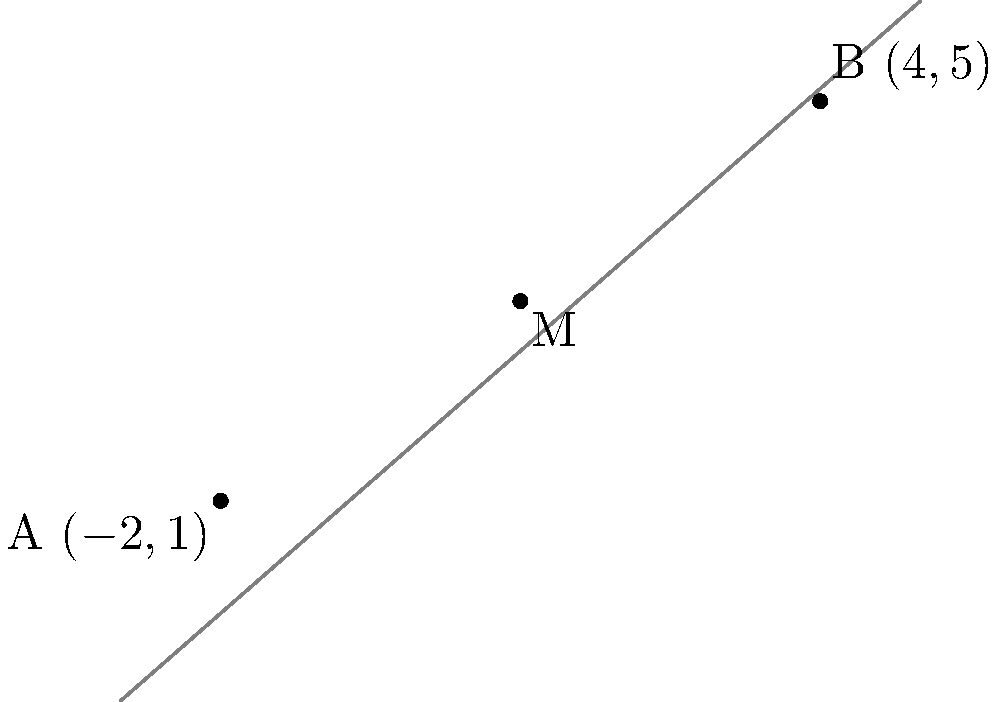As a rising star in your sport, you're analyzing team positions on a coordinate plane. Team Position 1 is at $(-2,1)$, and Team Position 2 is at $(4,5)$. To optimize your strategy, you need to find the midpoint between these two positions. What are the coordinates of this midpoint? To find the midpoint of a line segment connecting two points, we use the midpoint formula:

$$ M_x = \frac{x_1 + x_2}{2}, \quad M_y = \frac{y_1 + y_2}{2} $$

Where $(x_1, y_1)$ are the coordinates of the first point and $(x_2, y_2)$ are the coordinates of the second point.

For our problem:
1. Team Position 1: $(x_1, y_1) = (-2, 1)$
2. Team Position 2: $(x_2, y_2) = (4, 5)$

Let's calculate the x-coordinate of the midpoint:
$$ M_x = \frac{x_1 + x_2}{2} = \frac{-2 + 4}{2} = \frac{2}{2} = 1 $$

Now, let's calculate the y-coordinate of the midpoint:
$$ M_y = \frac{y_1 + y_2}{2} = \frac{1 + 5}{2} = \frac{6}{2} = 3 $$

Therefore, the midpoint coordinates are $(1, 3)$.
Answer: $(1, 3)$ 